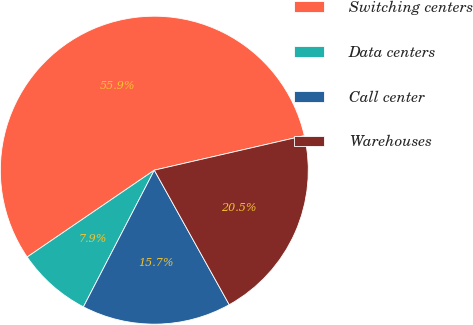Convert chart. <chart><loc_0><loc_0><loc_500><loc_500><pie_chart><fcel>Switching centers<fcel>Data centers<fcel>Call center<fcel>Warehouses<nl><fcel>55.94%<fcel>7.85%<fcel>15.7%<fcel>20.51%<nl></chart> 